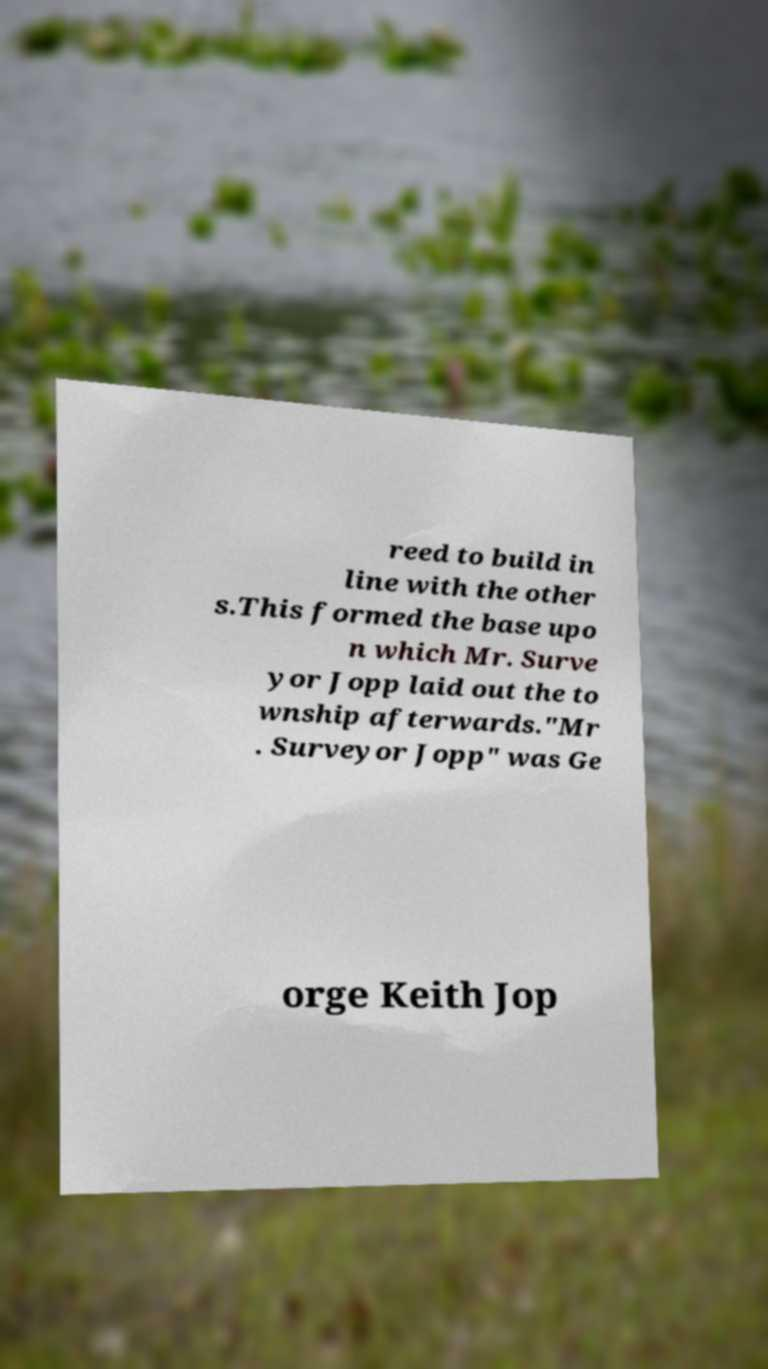Can you read and provide the text displayed in the image?This photo seems to have some interesting text. Can you extract and type it out for me? reed to build in line with the other s.This formed the base upo n which Mr. Surve yor Jopp laid out the to wnship afterwards."Mr . Surveyor Jopp" was Ge orge Keith Jop 